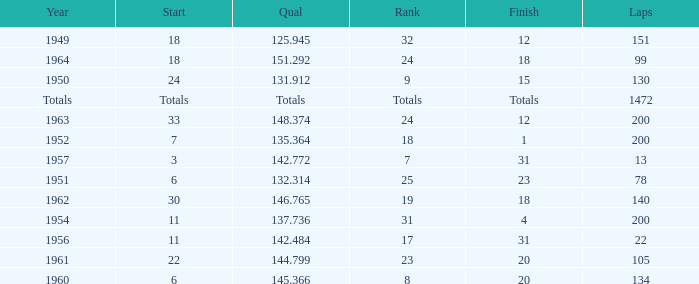Name the year for laps of 200 and rank of 24 1963.0. 